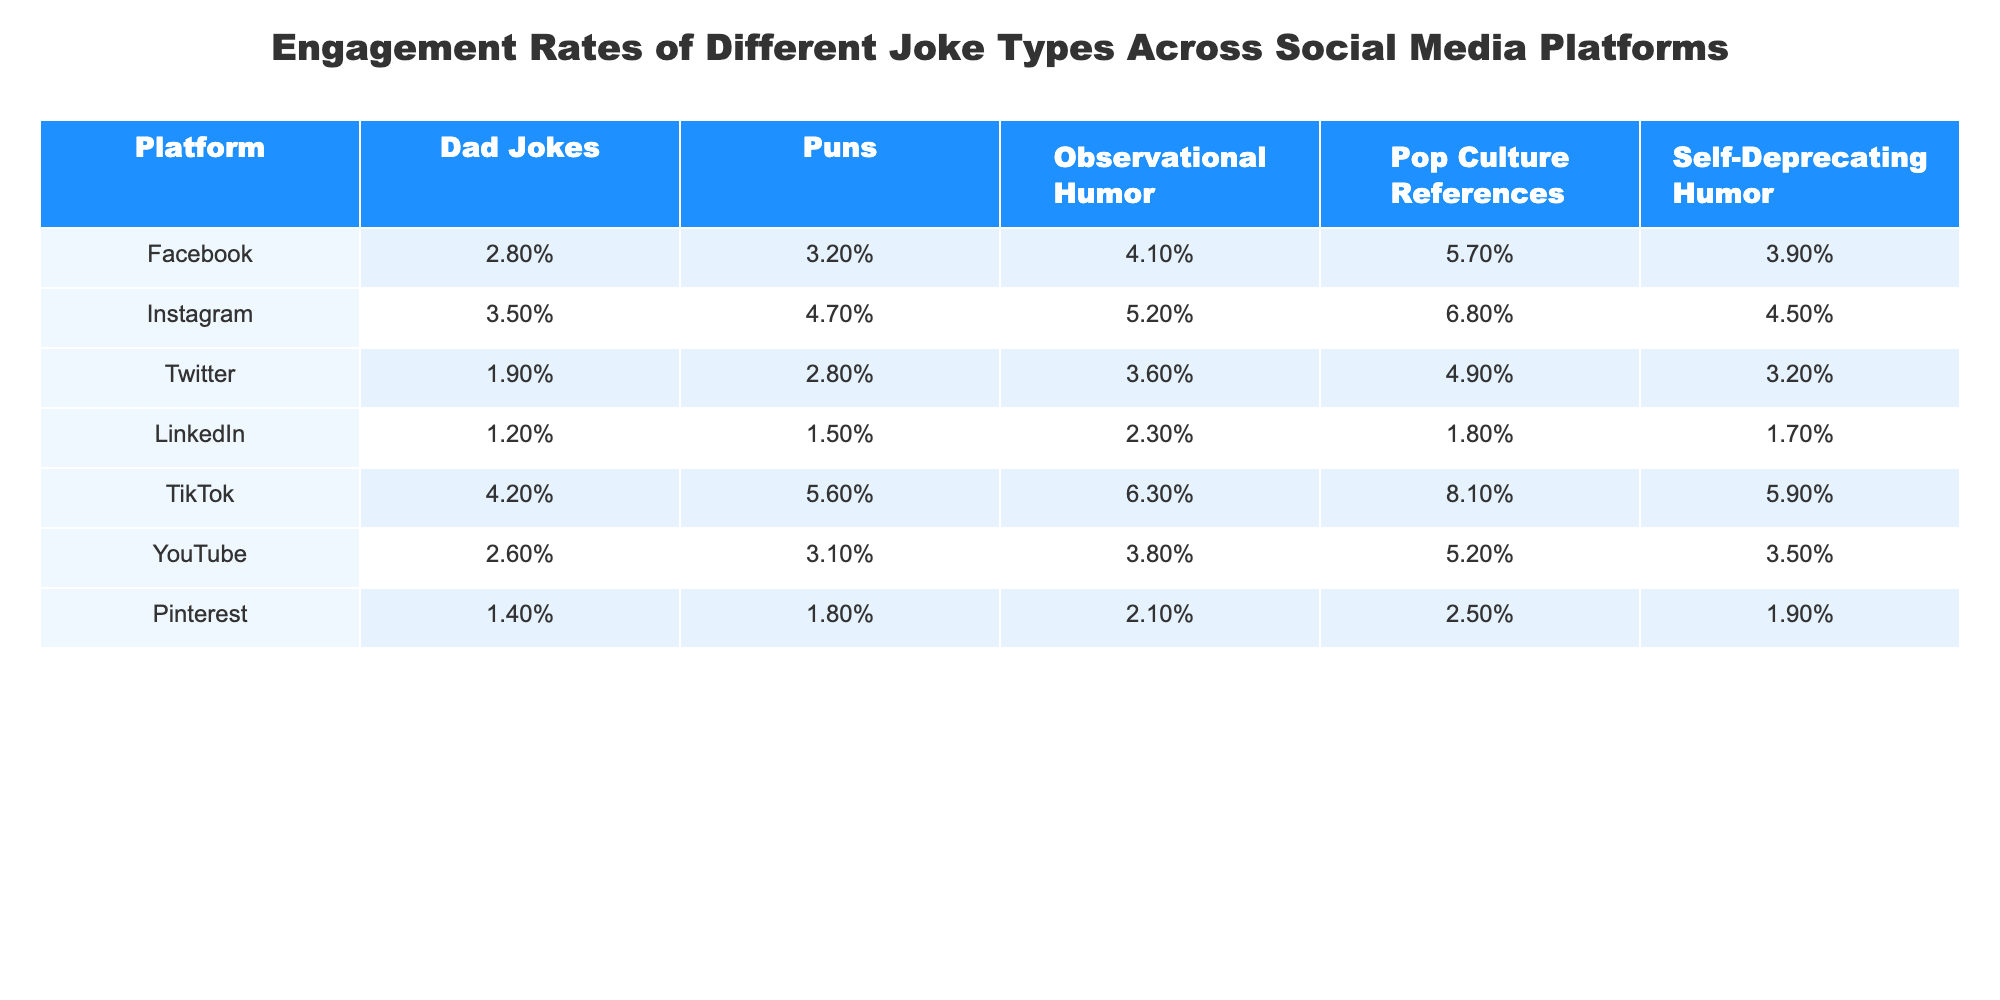What is the engagement rate for Pop Culture References on TikTok? The table shows that the engagement rate for Pop Culture References on TikTok is 8.1%.
Answer: 8.1% Which joke type has the highest engagement rate on Instagram? Looking at the Instagram row, the highest engagement rate is for Pop Culture References at 6.8%.
Answer: 6.8% What is the average engagement rate for Dad Jokes across all platforms? Adding the engagement rates for Dad Jokes: 2.8% + 3.5% + 1.9% + 1.2% + 4.2% + 2.6% + 1.4% = 17.6% and dividing by 7 gives an average of 17.6% / 7 = 2.51%.
Answer: 2.51% Is the engagement rate for Self-Deprecating Humor higher on Facebook than on Twitter? The table shows 3.9% for Facebook and 3.2% for Twitter, so Yes, it is higher on Facebook.
Answer: Yes What is the difference in engagement rates for Observational Humor between TikTok and LinkedIn? The engagement rate for Observational Humor on TikTok is 6.3% and on LinkedIn is 2.3%. The difference is 6.3% - 2.3% = 4.0%.
Answer: 4.0% Which platform has the lowest engagement rate for Puns? The table indicates that LinkedIn has the lowest engagement rate for Puns at 1.5%.
Answer: 1.5% What is the median engagement rate for Dad Jokes across all platforms? The Dad Joke engagement rates are: 2.8%, 3.5%, 1.9%, 1.2%, 4.2%, 2.6%, 1.4%. Sorting these values in ascending order gives: 1.2%, 1.4%, 1.9%, 2.6%, 2.8%, 3.5%, 4.2%. The median is the fourth value, which is 2.6%.
Answer: 2.6% Which joke type has consistently the highest engagement rate across all platforms? After reviewing all joke types and their engagement rates, Pop Culture References have the highest rates on every platform except LinkedIn, where it is lower than Observational Humor, but still comes in second highest overall.
Answer: Pop Culture References Which type of humor performed better on YouTube than on Facebook? Reviewing the engagement rates, the only type that performed better on YouTube is Pop Culture References (5.2% on YouTube versus 5.7% on Facebook), so the answer is No.
Answer: No What percentage of engagement for Puns does TikTok have compared to Facebook? TikTok has a Puns engagement rate of 5.6% and Facebook has 3.2%, so it is higher by 5.6% - 3.2% = 2.4%.
Answer: 2.4% 